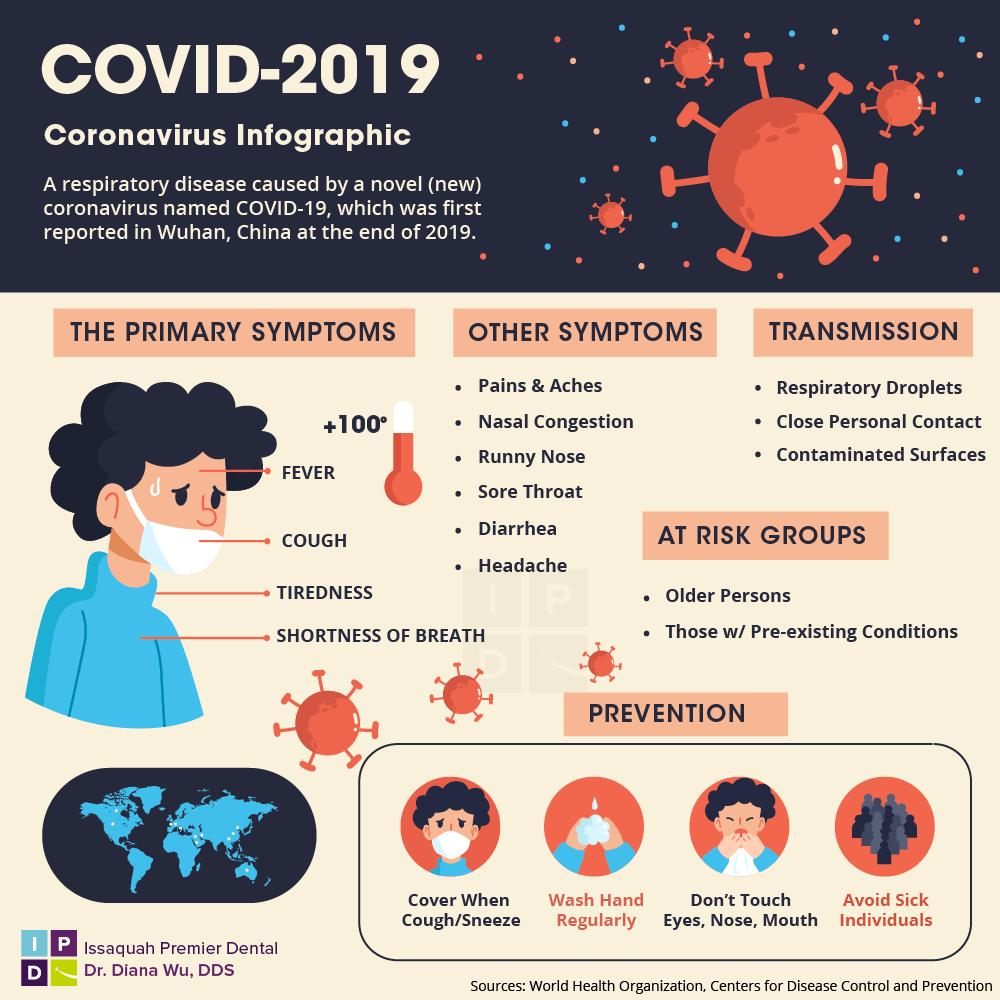Highlight a few significant elements in this photo. It is considered inappropriate to touch certain body parts, including the eyes, nose, and mouth. It is essential to cover one's mouth and nose when coughing or sneezing to prevent the spread of germs to others. Older people and individuals with pre-existing medical conditions are at a higher risk of being affected by COVID-19. There are multiple ways in which a person can be affected by the coronavirus. The average body temperature of a COVID-19 patient, also known as the coronavirus, is approximately 100 degrees Celsius. 